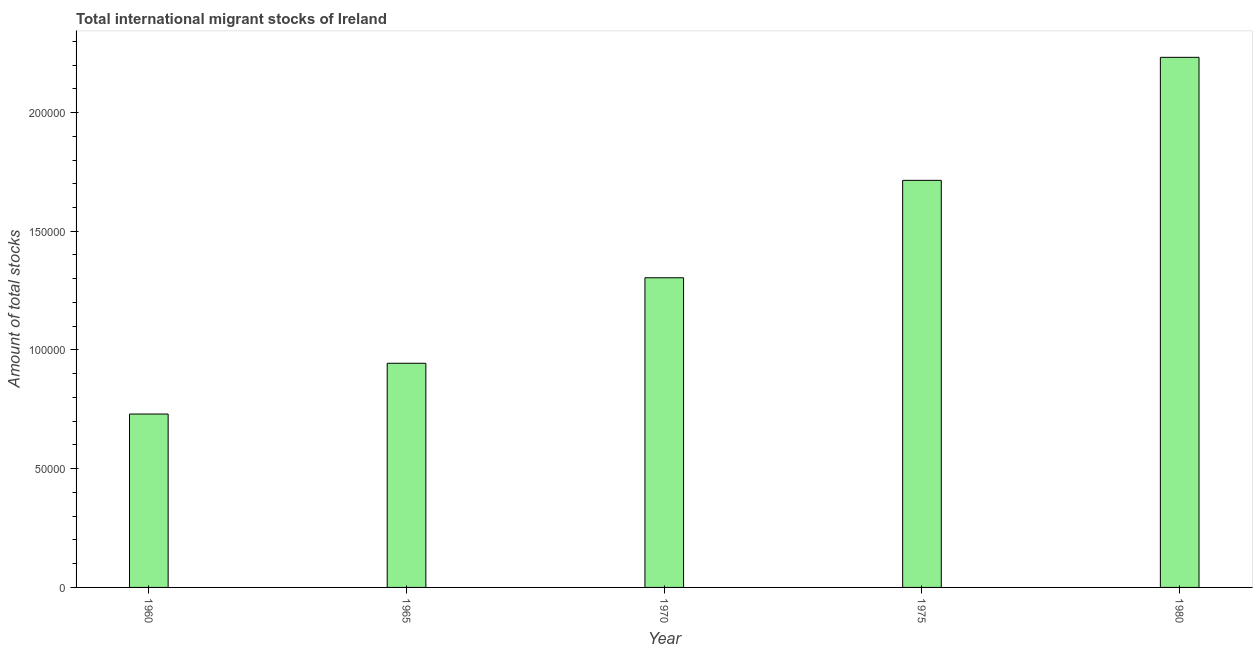Does the graph contain any zero values?
Offer a terse response. No. Does the graph contain grids?
Keep it short and to the point. No. What is the title of the graph?
Your response must be concise. Total international migrant stocks of Ireland. What is the label or title of the X-axis?
Ensure brevity in your answer.  Year. What is the label or title of the Y-axis?
Provide a succinct answer. Amount of total stocks. What is the total number of international migrant stock in 1965?
Provide a succinct answer. 9.44e+04. Across all years, what is the maximum total number of international migrant stock?
Offer a terse response. 2.23e+05. Across all years, what is the minimum total number of international migrant stock?
Give a very brief answer. 7.30e+04. What is the sum of the total number of international migrant stock?
Offer a terse response. 6.92e+05. What is the difference between the total number of international migrant stock in 1965 and 1980?
Provide a short and direct response. -1.29e+05. What is the average total number of international migrant stock per year?
Keep it short and to the point. 1.38e+05. What is the median total number of international migrant stock?
Offer a terse response. 1.30e+05. What is the ratio of the total number of international migrant stock in 1960 to that in 1965?
Your response must be concise. 0.77. Is the total number of international migrant stock in 1960 less than that in 1970?
Offer a very short reply. Yes. Is the difference between the total number of international migrant stock in 1960 and 1965 greater than the difference between any two years?
Keep it short and to the point. No. What is the difference between the highest and the second highest total number of international migrant stock?
Your response must be concise. 5.18e+04. Is the sum of the total number of international migrant stock in 1970 and 1975 greater than the maximum total number of international migrant stock across all years?
Keep it short and to the point. Yes. What is the difference between the highest and the lowest total number of international migrant stock?
Offer a very short reply. 1.50e+05. In how many years, is the total number of international migrant stock greater than the average total number of international migrant stock taken over all years?
Make the answer very short. 2. What is the Amount of total stocks in 1960?
Provide a short and direct response. 7.30e+04. What is the Amount of total stocks of 1965?
Your answer should be compact. 9.44e+04. What is the Amount of total stocks of 1970?
Your answer should be compact. 1.30e+05. What is the Amount of total stocks in 1975?
Make the answer very short. 1.71e+05. What is the Amount of total stocks in 1980?
Ensure brevity in your answer.  2.23e+05. What is the difference between the Amount of total stocks in 1960 and 1965?
Make the answer very short. -2.14e+04. What is the difference between the Amount of total stocks in 1960 and 1970?
Offer a terse response. -5.74e+04. What is the difference between the Amount of total stocks in 1960 and 1975?
Offer a very short reply. -9.84e+04. What is the difference between the Amount of total stocks in 1960 and 1980?
Offer a terse response. -1.50e+05. What is the difference between the Amount of total stocks in 1965 and 1970?
Ensure brevity in your answer.  -3.60e+04. What is the difference between the Amount of total stocks in 1965 and 1975?
Offer a very short reply. -7.70e+04. What is the difference between the Amount of total stocks in 1965 and 1980?
Your answer should be compact. -1.29e+05. What is the difference between the Amount of total stocks in 1970 and 1975?
Keep it short and to the point. -4.10e+04. What is the difference between the Amount of total stocks in 1970 and 1980?
Your answer should be compact. -9.28e+04. What is the difference between the Amount of total stocks in 1975 and 1980?
Your answer should be very brief. -5.18e+04. What is the ratio of the Amount of total stocks in 1960 to that in 1965?
Offer a terse response. 0.77. What is the ratio of the Amount of total stocks in 1960 to that in 1970?
Provide a succinct answer. 0.56. What is the ratio of the Amount of total stocks in 1960 to that in 1975?
Your answer should be compact. 0.43. What is the ratio of the Amount of total stocks in 1960 to that in 1980?
Ensure brevity in your answer.  0.33. What is the ratio of the Amount of total stocks in 1965 to that in 1970?
Make the answer very short. 0.72. What is the ratio of the Amount of total stocks in 1965 to that in 1975?
Provide a succinct answer. 0.55. What is the ratio of the Amount of total stocks in 1965 to that in 1980?
Provide a short and direct response. 0.42. What is the ratio of the Amount of total stocks in 1970 to that in 1975?
Offer a very short reply. 0.76. What is the ratio of the Amount of total stocks in 1970 to that in 1980?
Make the answer very short. 0.58. What is the ratio of the Amount of total stocks in 1975 to that in 1980?
Make the answer very short. 0.77. 